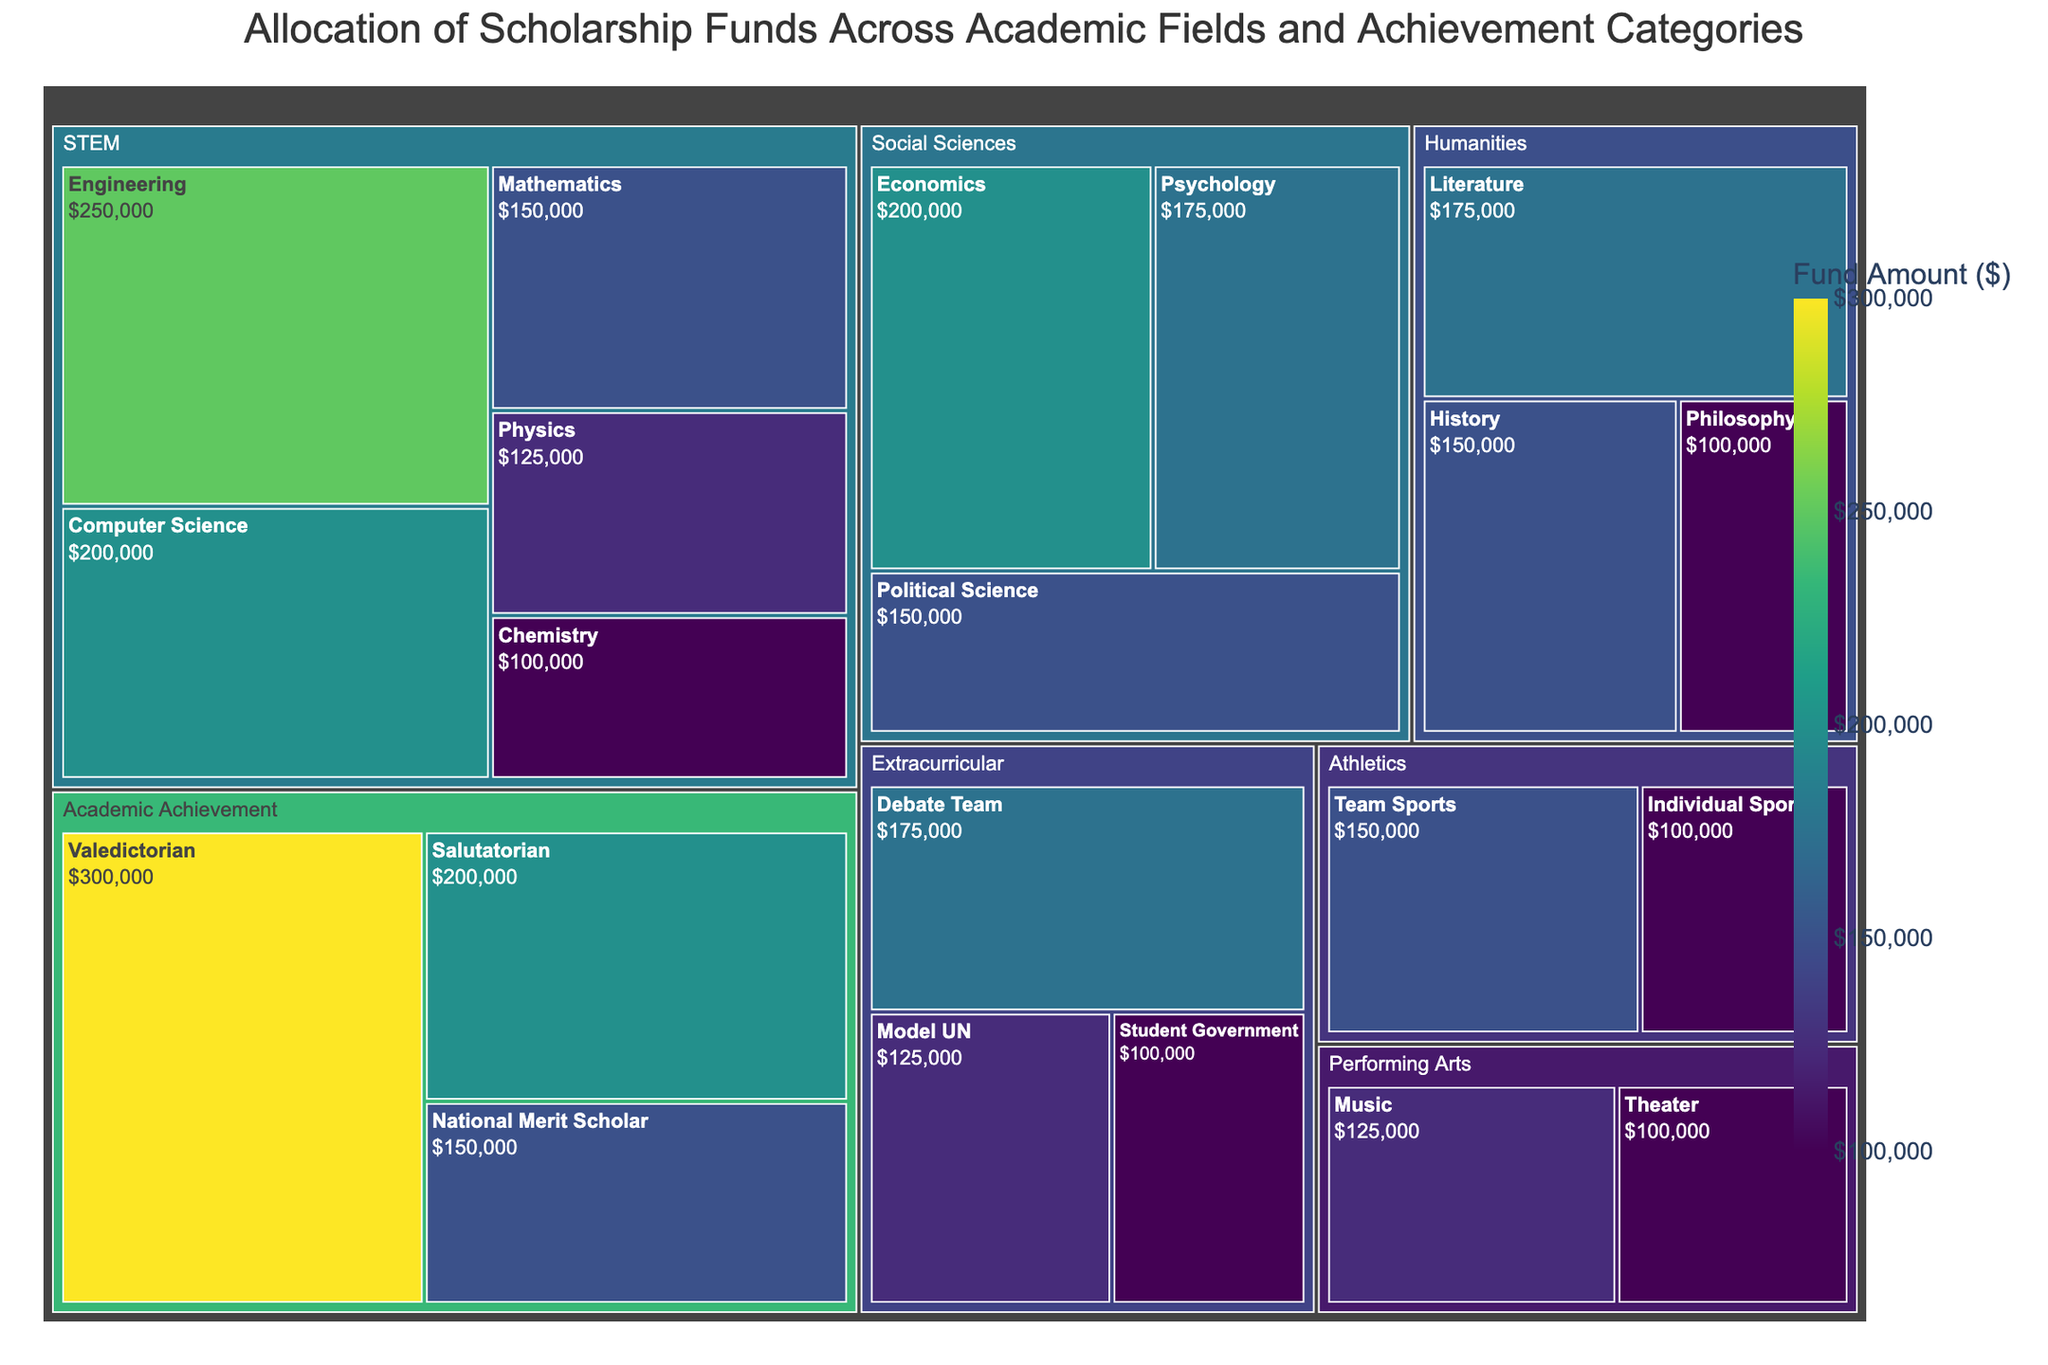Which academic field receives the highest allocation of scholarship funds? Look at the treemap and identify the largest block. The largest block corresponds to the category with the biggest allocation.
Answer: Academic Achievement Which subcategory under STEM receives the highest scholarship fund? Identify the subcategories under the STEM category and find the one with the largest area.
Answer: Engineering By how much does the scholarship allocation for Valedictorian exceed Salutatorian? Locate the Valedictorian and Salutatorian subcategories under Academic Achievement. Subtract the amount of Salutatorian from Valedictorian.
Answer: $100,000 What is the difference in scholarship funds between the top two funded fields under Humanities? Identify the top two subcategories under Humanities (Literature and History) and subtract their values.
Answer: $25,000 Which categories have a total allocation of scholarship funds greater than $300,000? Sum the funds for each main category and check which ones exceed $300,000. For instance, the sum of all STEM subcategories is $825,000, so STEM qualifies.
Answer: STEM, Academic Achievement How do the funds allocated to Computer Science compare to Economics? Identify the values of Computer Science under STEM and Economics under Social Sciences. Compare the amounts.
Answer: Computer Science: $200,000, Economics: $200,000 What percentage of the total scholarship funds is allocated to Athletics? Sum the total funds for all categories. Divide the total Athletic funds by this sum and multiply by 100 to find the percentage. Total funds = $2,750,000. Athletics = $250,000. (250,000 / 2,750,000) * 100
Answer: Approximately 9.09% How does the fund allocation for Debate Team compare with that for Model UN? Locate the Debate Team and Model UN subcategories under Extracurricular. Compare their values.
Answer: Debate Team: $175,000, Model UN: $125,000 Which subcategories in the Performing Arts have nearly equal scholarship funds, and what are their values? Identify the subcategories under Performing Arts and check their values. Find the ones that are close or equal.
Answer: Music: $125,000, Theater: $100,000 